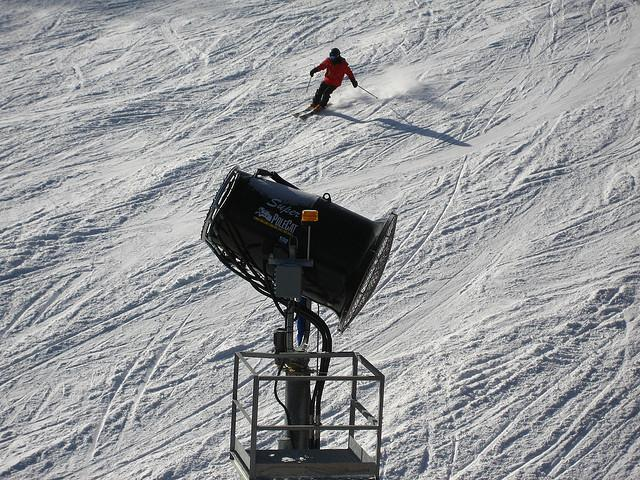What is the person in the jacket holding? ski poles 